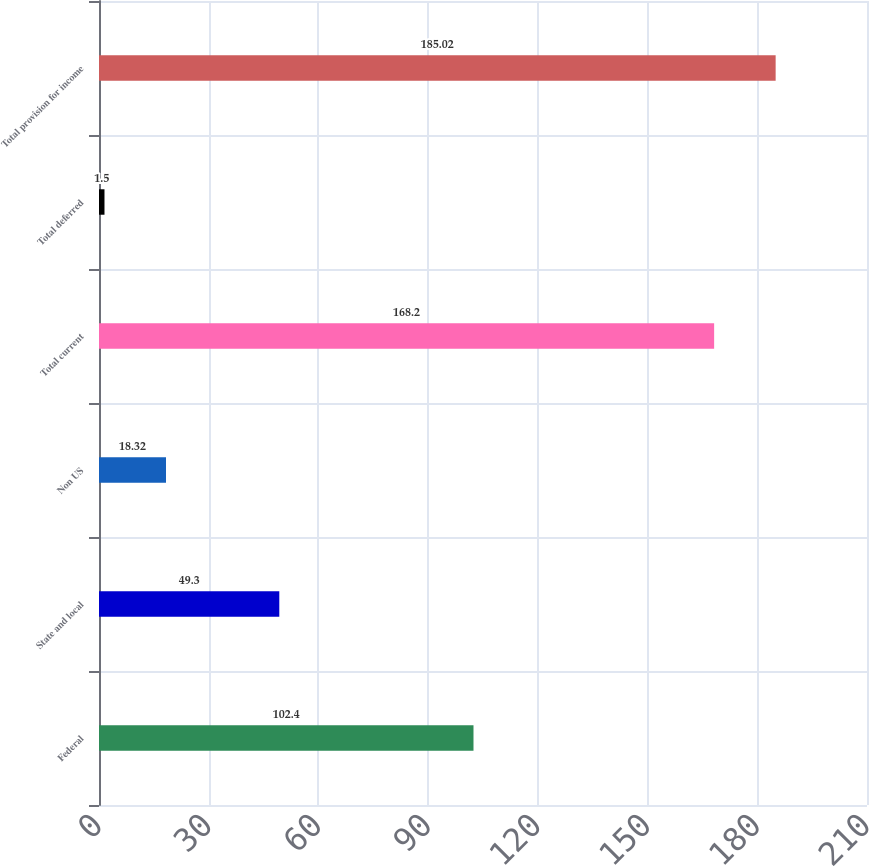Convert chart to OTSL. <chart><loc_0><loc_0><loc_500><loc_500><bar_chart><fcel>Federal<fcel>State and local<fcel>Non US<fcel>Total current<fcel>Total deferred<fcel>Total provision for income<nl><fcel>102.4<fcel>49.3<fcel>18.32<fcel>168.2<fcel>1.5<fcel>185.02<nl></chart> 